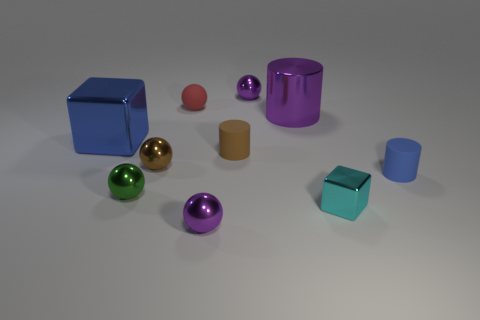Subtract all purple metallic spheres. How many spheres are left? 3 Subtract all purple spheres. How many spheres are left? 3 Subtract 1 cylinders. How many cylinders are left? 2 Subtract all cubes. How many objects are left? 8 Subtract all green spheres. How many blue cubes are left? 1 Add 7 large cylinders. How many large cylinders exist? 8 Subtract 1 brown cylinders. How many objects are left? 9 Subtract all cyan cubes. Subtract all red cylinders. How many cubes are left? 1 Subtract all small blue cylinders. Subtract all metallic spheres. How many objects are left? 5 Add 2 rubber balls. How many rubber balls are left? 3 